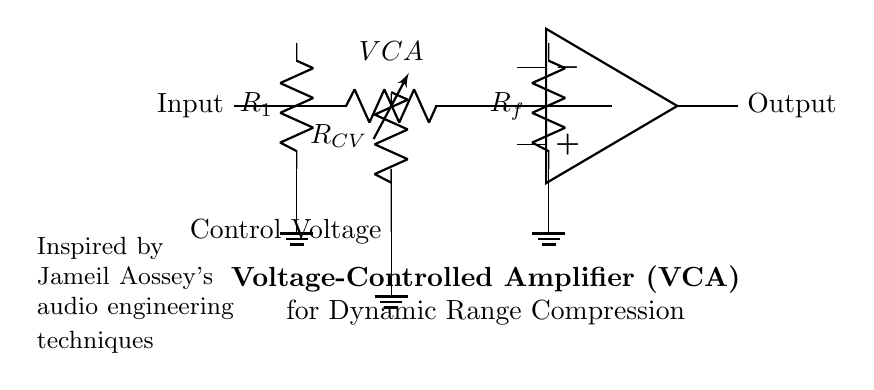What is the function of the component labeled VCA? The VCA stands for Voltage-Controlled Amplifier, which adjusts its gain according to a control voltage applied to it, playing a key role in dynamic range compression.
Answer: Voltage-Controlled Amplifier What does R1 represent in the circuit? R1 is a resistor that acts as part of the input stage, limiting current and helping to set the circuit's gain.
Answer: Resistor How many resistors are present in the circuit? There are three resistors in the circuit: R1, R_f, and R_CV.
Answer: Three What is the purpose of the Control Voltage? The Control Voltage modifies the gain of the VCA, allowing for dynamic adjustment based on the audio signal's level, essential for effective compression.
Answer: Modifies gain Which component is connected to the output? The output is connected to the op amp, which processes the amplified signal before it is sent out.
Answer: Op amp What do the grounds in the circuit indicate? The grounds represent the reference point for the circuit's voltage levels, ensuring that all components share a common return path for current, maintaining stability.
Answer: Reference point What is the overall purpose of this circuit diagram? The diagram represents a voltage-controlled amplifier circuit designed for dynamic range compression in audio processing, optimizing sound quality.
Answer: Dynamic range compression 